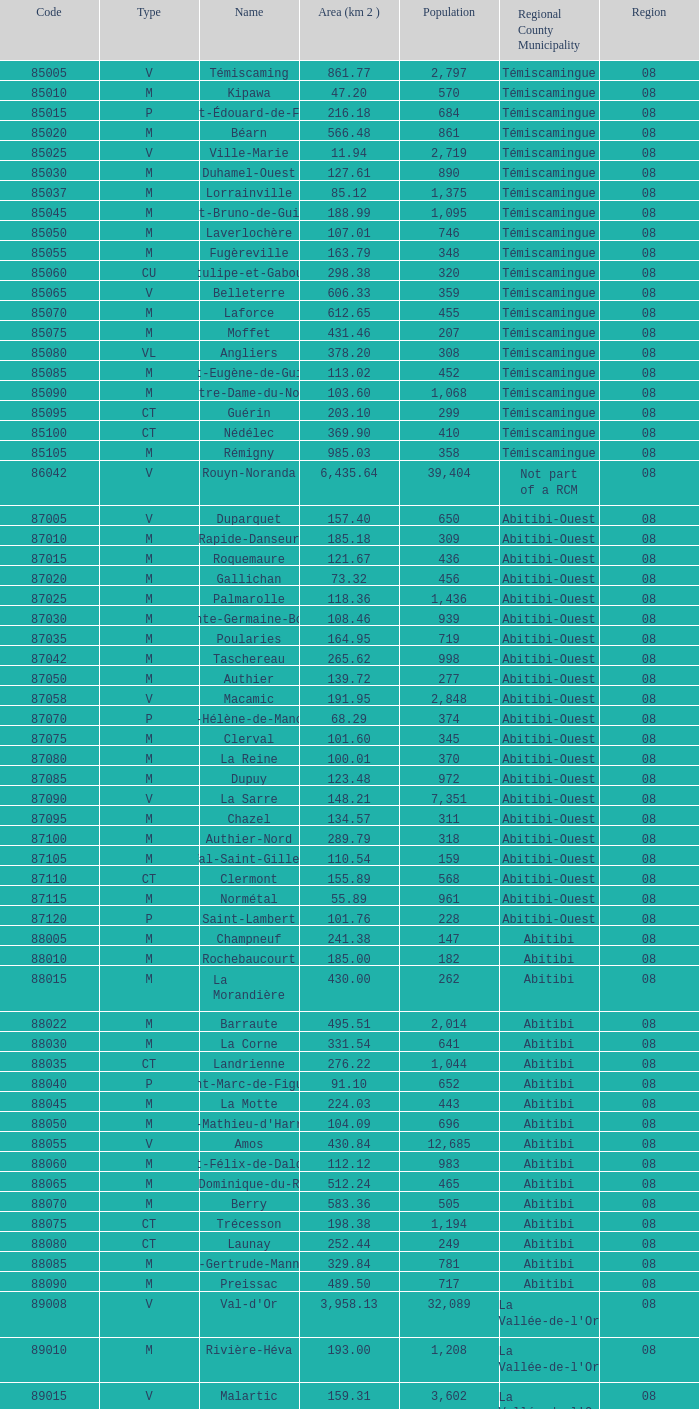What local government area is home to 719 residents and spans more than 108.46 square kilometers? Abitibi-Ouest. 